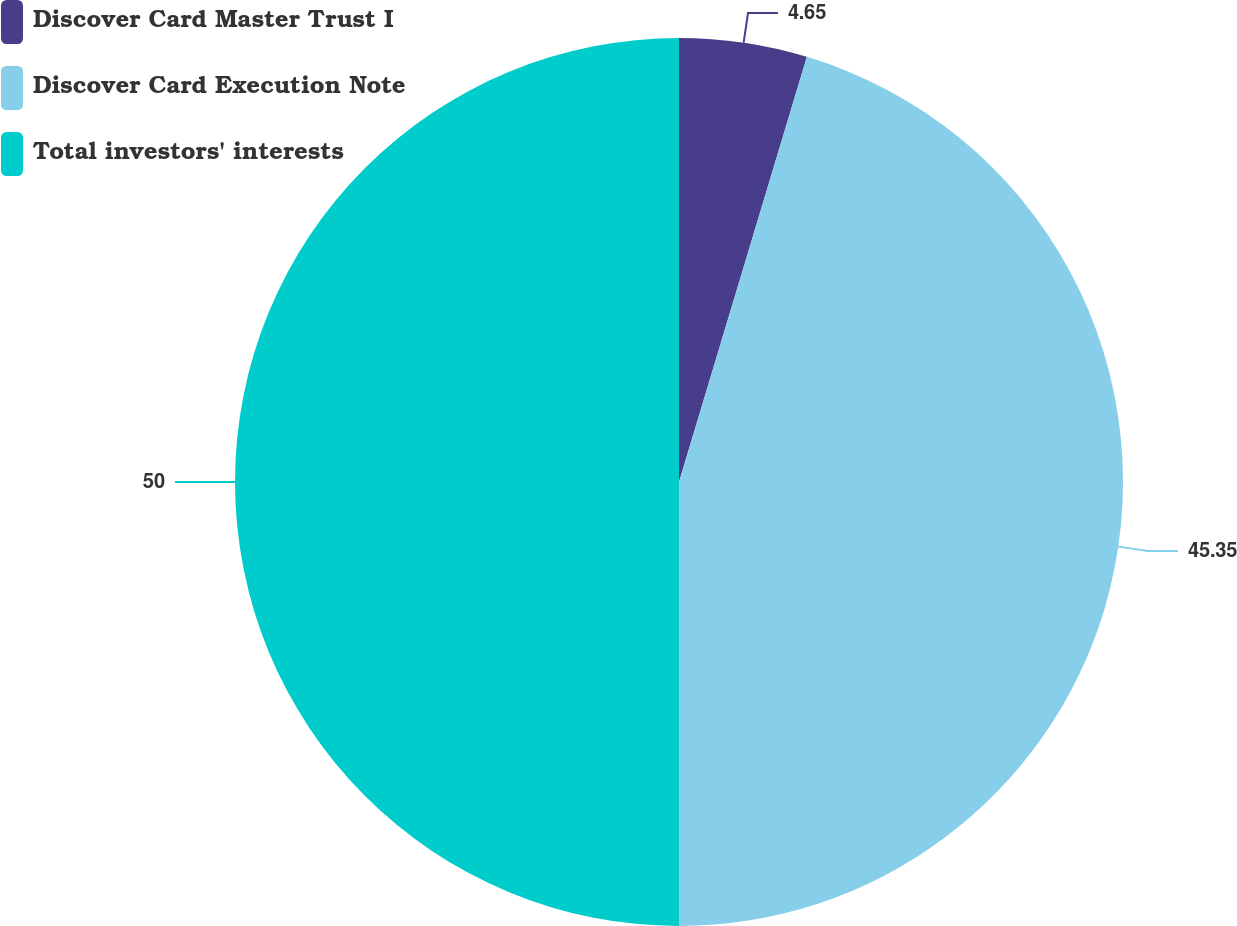Convert chart to OTSL. <chart><loc_0><loc_0><loc_500><loc_500><pie_chart><fcel>Discover Card Master Trust I<fcel>Discover Card Execution Note<fcel>Total investors' interests<nl><fcel>4.65%<fcel>45.35%<fcel>50.0%<nl></chart> 